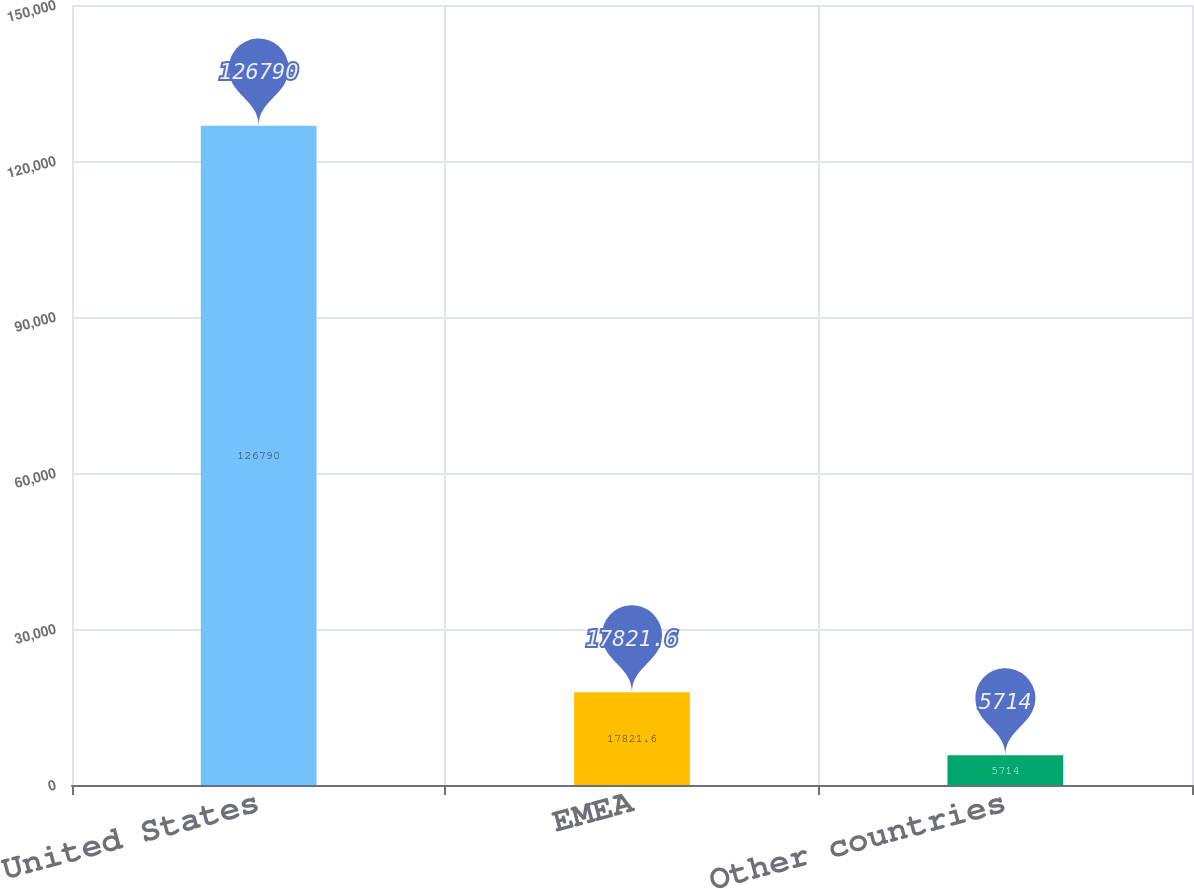<chart> <loc_0><loc_0><loc_500><loc_500><bar_chart><fcel>United States<fcel>EMEA<fcel>Other countries<nl><fcel>126790<fcel>17821.6<fcel>5714<nl></chart> 